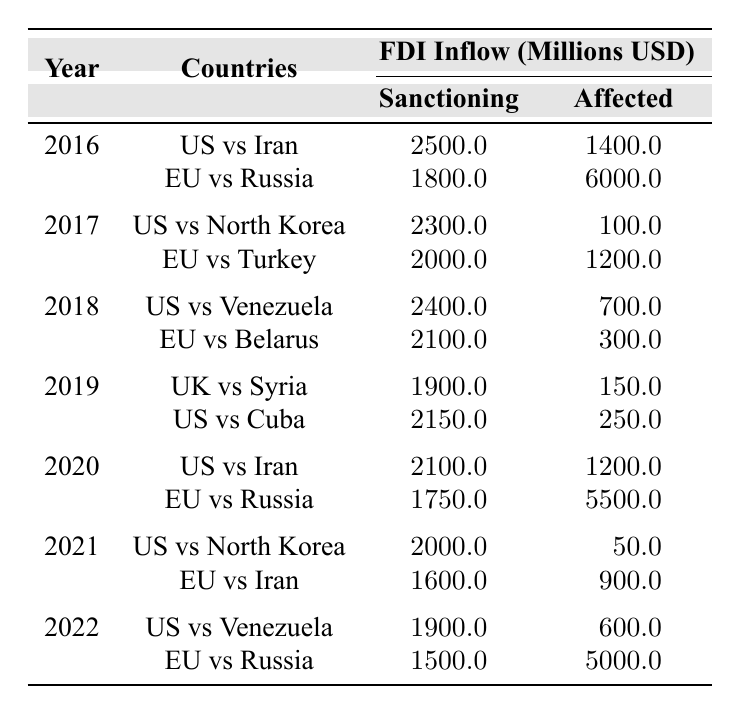What was the FDI inflow from the United States to Iran in 2016? The table shows that in 2016, the FDI inflow from the United States to Iran was listed as 2500 million USD.
Answer: 2500 million USD Which year saw the highest FDI inflow from the European Union to Russia? In 2016, the FDI inflow from the European Union to Russia was 1800 million USD, which is higher than the 1750 million USD recorded in 2020. Therefore, 2016 had the highest inflow.
Answer: 2016 What is the total FDI inflow from the United States to both Iran and Venezuela in 2022? The FDI inflow from the United States to Iran in 2022 was 1900 million USD, and to Venezuela was the same amount, so 1900 + 1900 equals 3800 million USD.
Answer: 3800 million USD In 2019, which country had a greater FDI inflow, the United States to Cuba or the United Kingdom to Syria? The FDI inflow from the United States to Cuba in 2019 was 2150 million USD, while the United Kingdom to Syria was 1900 million USD. Since 2150 is greater than 1900, the US to Cuba had a greater inflow.
Answer: United States to Cuba Was there a year where the FDI inflow from sanctioning countries to their affected nations dropped compared to the previous year? Yes, in 2021, the FDI inflow from the United States to North Korea dropped to 2000 million USD from 2300 million USD in 2017. Therefore, it declined for this pair compared to the earlier years.
Answer: Yes What is the difference in FDI inflows from the European Union to Russia between 2020 and 2016? In 2020, the inflow was 1750 million USD and in 2016 it was 1800 million USD. The difference is 1800 - 1750 = 50 million USD.
Answer: 50 million USD What is the average FDI inflow from the European Union to Belarus and Turkey during the years available? The inflow for Belarus in 2018 was 2100 million USD and for Turkey in 2017 was 2000 million USD. To find the average, sum them (2100+2000) and divide by 2, resulting in 2050 million USD.
Answer: 2050 million USD Which year had the lowest FDI inflow from the United States to North Korea? In 2021, the FDI inflow from the United States to North Korea dropped to 2000 million USD, which is lower than the 2300 million USD seen in 2017.
Answer: 2021 How did the FDI inflow to Iran from the United States compare from 2016 to 2020? In 2016, the inflow was 2500 million USD, and in 2020, it dropped to 2100 million USD. This means there was a decrease of 400 million USD from 2016 to 2020.
Answer: Decrease of 400 million USD What is the total FDI inflow from the United States to the affected nations listed over the years? Adding the inflows: (2500 + 2300 + 2400 + 2150 + 2100 + 2000 + 1900) gives us a total of 15150 million USD.
Answer: 15150 million USD Was the FDI inflow from the European Union to Iran in 2021 higher than the inflow to Russia in 2022? The FDI inflow to Iran in 2021 was 1600 million USD, while the inflow to Russia in 2022 was 1500 million USD. Therefore, the inflow to Iran was higher.
Answer: Yes 